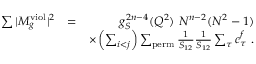Convert formula to latex. <formula><loc_0><loc_0><loc_500><loc_500>\begin{array} { r l r } { \sum | M _ { g } ^ { v i o l } | ^ { 2 } } & { = } & { g _ { S } ^ { 2 n - 4 } ( Q ^ { 2 } ) N ^ { n - 2 } ( N ^ { 2 } - 1 ) } \\ & { \times \left ( \sum _ { i < j } \right ) \sum _ { p e r m } \frac { 1 } { S _ { 1 2 } } \frac { 1 } { S _ { 1 2 } } \sum _ { \tau } c _ { \tau } ^ { f } . } \end{array}</formula> 